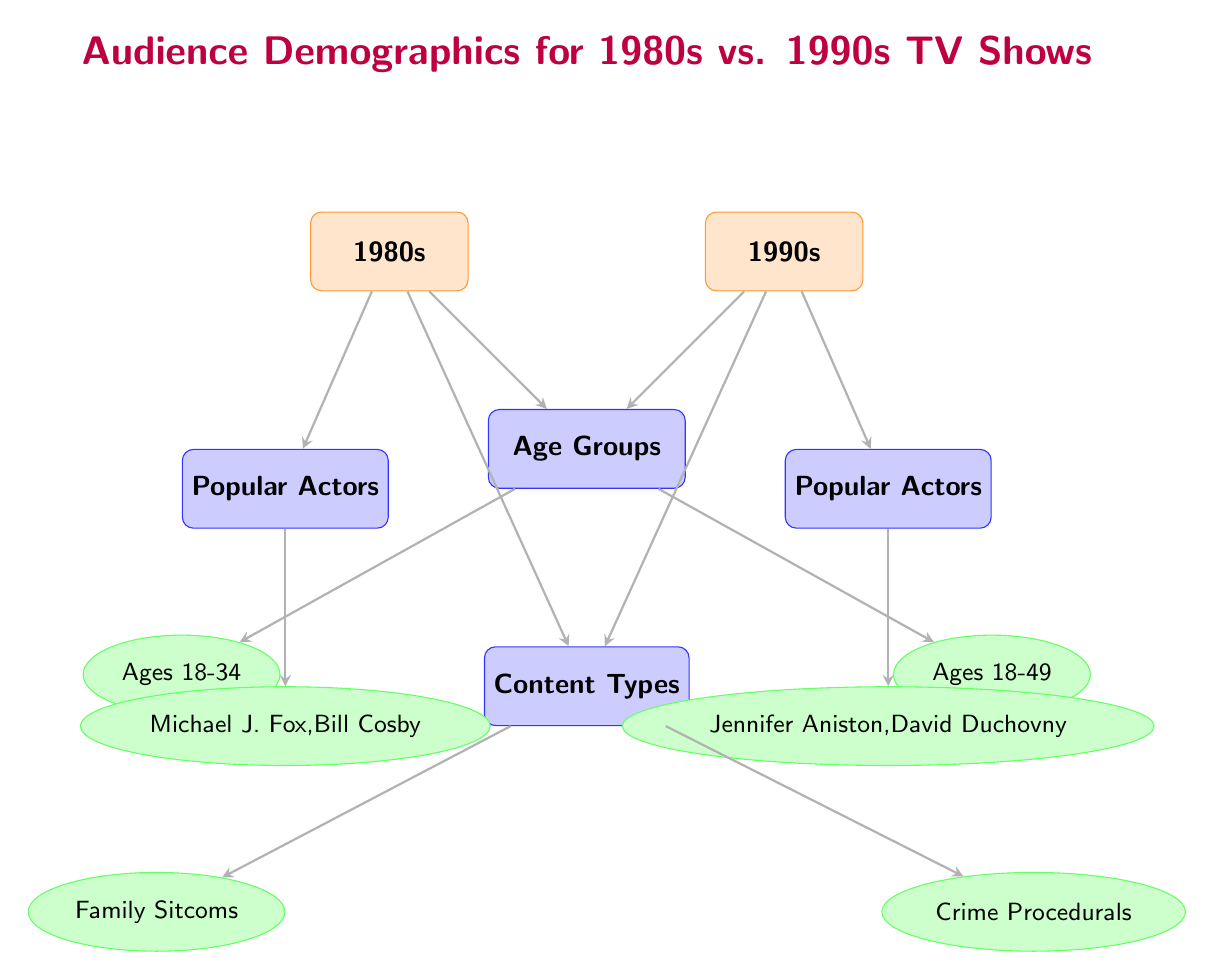What age group represents the audience for 1980s TV shows? The diagram indicates that the age group for 1980s TV shows is represented as "Ages 18-34," which is shown directly beneath the 1980s node.
Answer: Ages 18-34 What is the primary content type for 1990s TV shows? The diagram shows that the primary content type associated with the 1990s is "Crime Procedurals," located beneath the content type node for the 1990s.
Answer: Crime Procedurals How many popular actors are listed for 1980s TV shows? The diagram lists two popular actors for 1980s TV shows, specifically "Michael J. Fox" and "Bill Cosby," under the respective node labeled "Popular Actors."
Answer: 2 Which age group expanded from the 1980s to the 1990s? The diagram indicates that the age group for the 1990s is "Ages 18-49," which expands upon the previous age group of "Ages 18-34" from the 1980s. Therefore, the answer pertains to the inclusion of older viewers.
Answer: Ages 18-49 What are the lead actors for 1990s TV shows? According to the diagram, the lead actors for 1990s TV shows are "Jennifer Aniston" and "David Duchovny," as listed under the node for popular actors associated with the 1990s.
Answer: Jennifer Aniston, David Duchovny Which category is directly above the subcategory "Family Sitcoms"? The diagram portrays "Content Types" as the category directly above the subcategory "Family Sitcoms," connecting them through a downward arrow from the content type node.
Answer: Content Types What is the relationship between the 1980s and the "Age Groups" category? The relationship is that the node "Age Groups" is directly connected to the 1980s node through an arrow pointing downwards, indicating that the demographic aspect is associated with that time period.
Answer: Arrow connection How many categories are presented in the diagram? There are three categories presented in the diagram: "Age Groups," "Content Types," and "Popular Actors," making a total of three distinct categories.
Answer: 3 